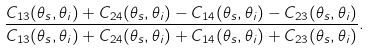Convert formula to latex. <formula><loc_0><loc_0><loc_500><loc_500>\frac { C _ { 1 3 } ( \theta _ { s } , \theta _ { i } ) + C _ { 2 4 } ( \theta _ { s } , \theta _ { i } ) - C _ { 1 4 } ( \theta _ { s } , \theta _ { i } ) - C _ { 2 3 } ( \theta _ { s } , \theta _ { i } ) } { C _ { 1 3 } ( \theta _ { s } , \theta _ { i } ) + C _ { 2 4 } ( \theta _ { s } , \theta _ { i } ) + C _ { 1 4 } ( \theta _ { s } , \theta _ { i } ) + C _ { 2 3 } ( \theta _ { s } , \theta _ { i } ) } .</formula> 